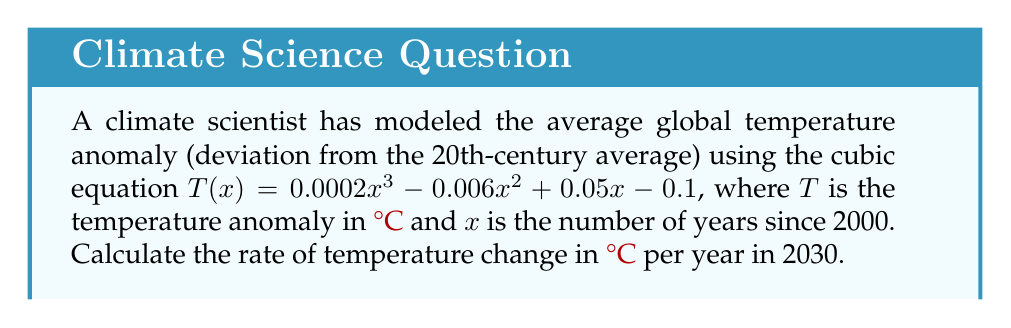Give your solution to this math problem. To find the rate of temperature change in 2030, we need to calculate the derivative of the temperature function $T(x)$ and evaluate it at $x = 30$ (since 2030 is 30 years after 2000).

1. Given temperature function:
   $T(x) = 0.0002x^3 - 0.006x^2 + 0.05x - 0.1$

2. Calculate the derivative $T'(x)$:
   $T'(x) = 0.0006x^2 - 0.012x + 0.05$

3. Evaluate $T'(x)$ at $x = 30$:
   $T'(30) = 0.0006(30)^2 - 0.012(30) + 0.05$
   $= 0.0006(900) - 0.36 + 0.05$
   $= 0.54 - 0.36 + 0.05$
   $= 0.23$

Therefore, the rate of temperature change in 2030 is 0.23 °C per year.
Answer: 0.23 °C/year 